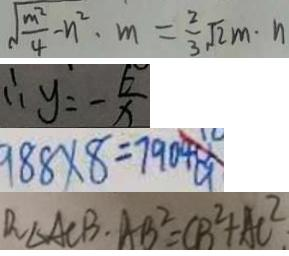Convert formula to latex. <formula><loc_0><loc_0><loc_500><loc_500>\sqrt { \frac { m ^ { 2 } } { 4 } } - n ^ { 2 } \cdot m = \frac { 2 } { 3 } \sqrt { 2 } m \cdot n 
 \therefore y = - \frac { 6 } { x } 
 9 8 8 \times 8 = 7 9 0 4 a 
 R _ { \Delta } A C B \cdot A B ^ { 2 } = C B ^ { 2 } + A C ^ { 2 }</formula> 